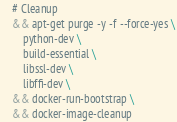Convert code to text. <code><loc_0><loc_0><loc_500><loc_500><_Dockerfile_>    # Cleanup
    && apt-get purge -y -f --force-yes \
        python-dev \
        build-essential \
        libssl-dev \
        libffi-dev \
    && docker-run-bootstrap \
    && docker-image-cleanup
</code> 